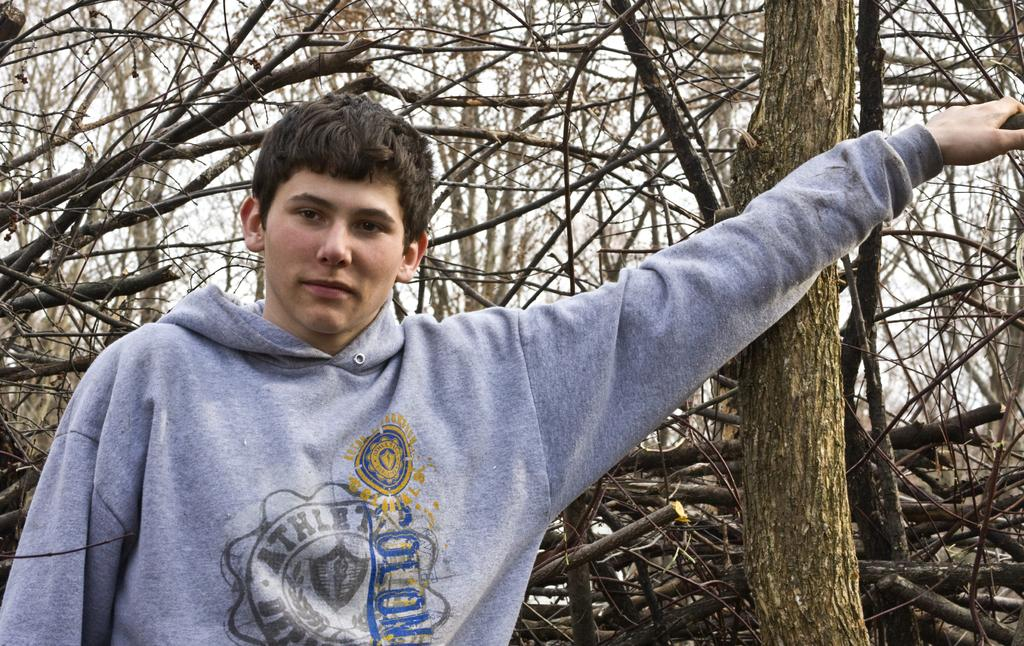What is the main subject of the picture? There is a person in the middle of the picture. What can be seen in the background of the picture? There are trees in the background of the picture. What type of powder is being used by the person in the picture? There is no powder visible in the image, and the person's actions are not described, so it cannot be determined if they are using any powder. 